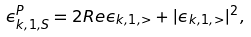Convert formula to latex. <formula><loc_0><loc_0><loc_500><loc_500>\epsilon _ { k , 1 , S } ^ { P } = 2 R e \epsilon _ { k , 1 , > } + | \epsilon _ { k , 1 , > } | ^ { 2 } ,</formula> 